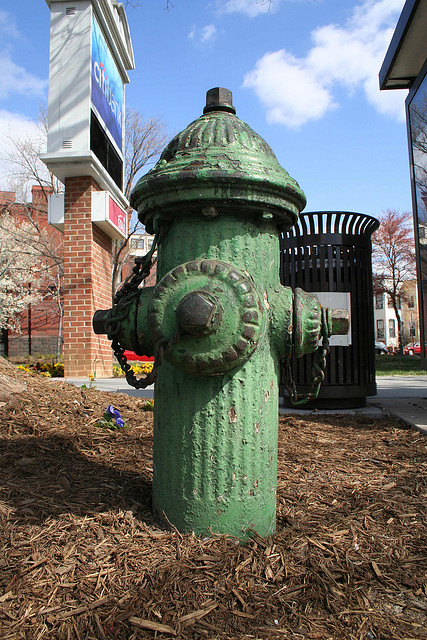Please transcribe the text information in this image. citybank 